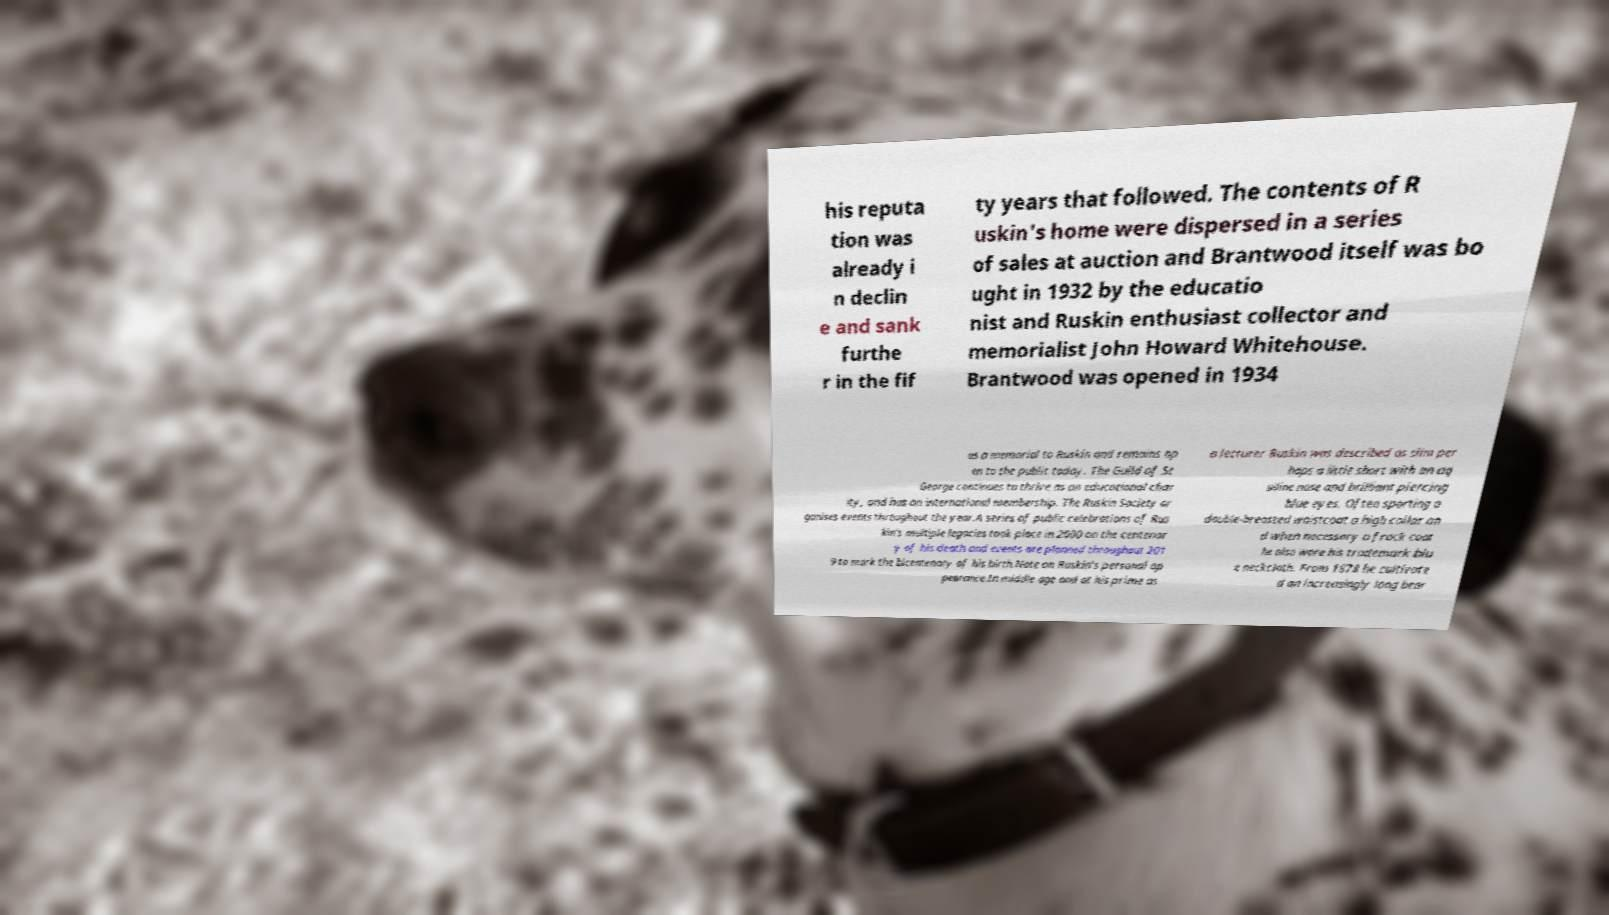There's text embedded in this image that I need extracted. Can you transcribe it verbatim? his reputa tion was already i n declin e and sank furthe r in the fif ty years that followed. The contents of R uskin's home were dispersed in a series of sales at auction and Brantwood itself was bo ught in 1932 by the educatio nist and Ruskin enthusiast collector and memorialist John Howard Whitehouse. Brantwood was opened in 1934 as a memorial to Ruskin and remains op en to the public today. The Guild of St George continues to thrive as an educational char ity, and has an international membership. The Ruskin Society or ganises events throughout the year.A series of public celebrations of Rus kin's multiple legacies took place in 2000 on the centenar y of his death and events are planned throughout 201 9 to mark the bicentenary of his birth.Note on Ruskin's personal ap pearance.In middle age and at his prime as a lecturer Ruskin was described as slim per haps a little short with an aq uiline nose and brilliant piercing blue eyes. Often sporting a double-breasted waistcoat a high collar an d when necessary a frock coat he also wore his trademark blu e neckcloth. From 1878 he cultivate d an increasingly long bear 